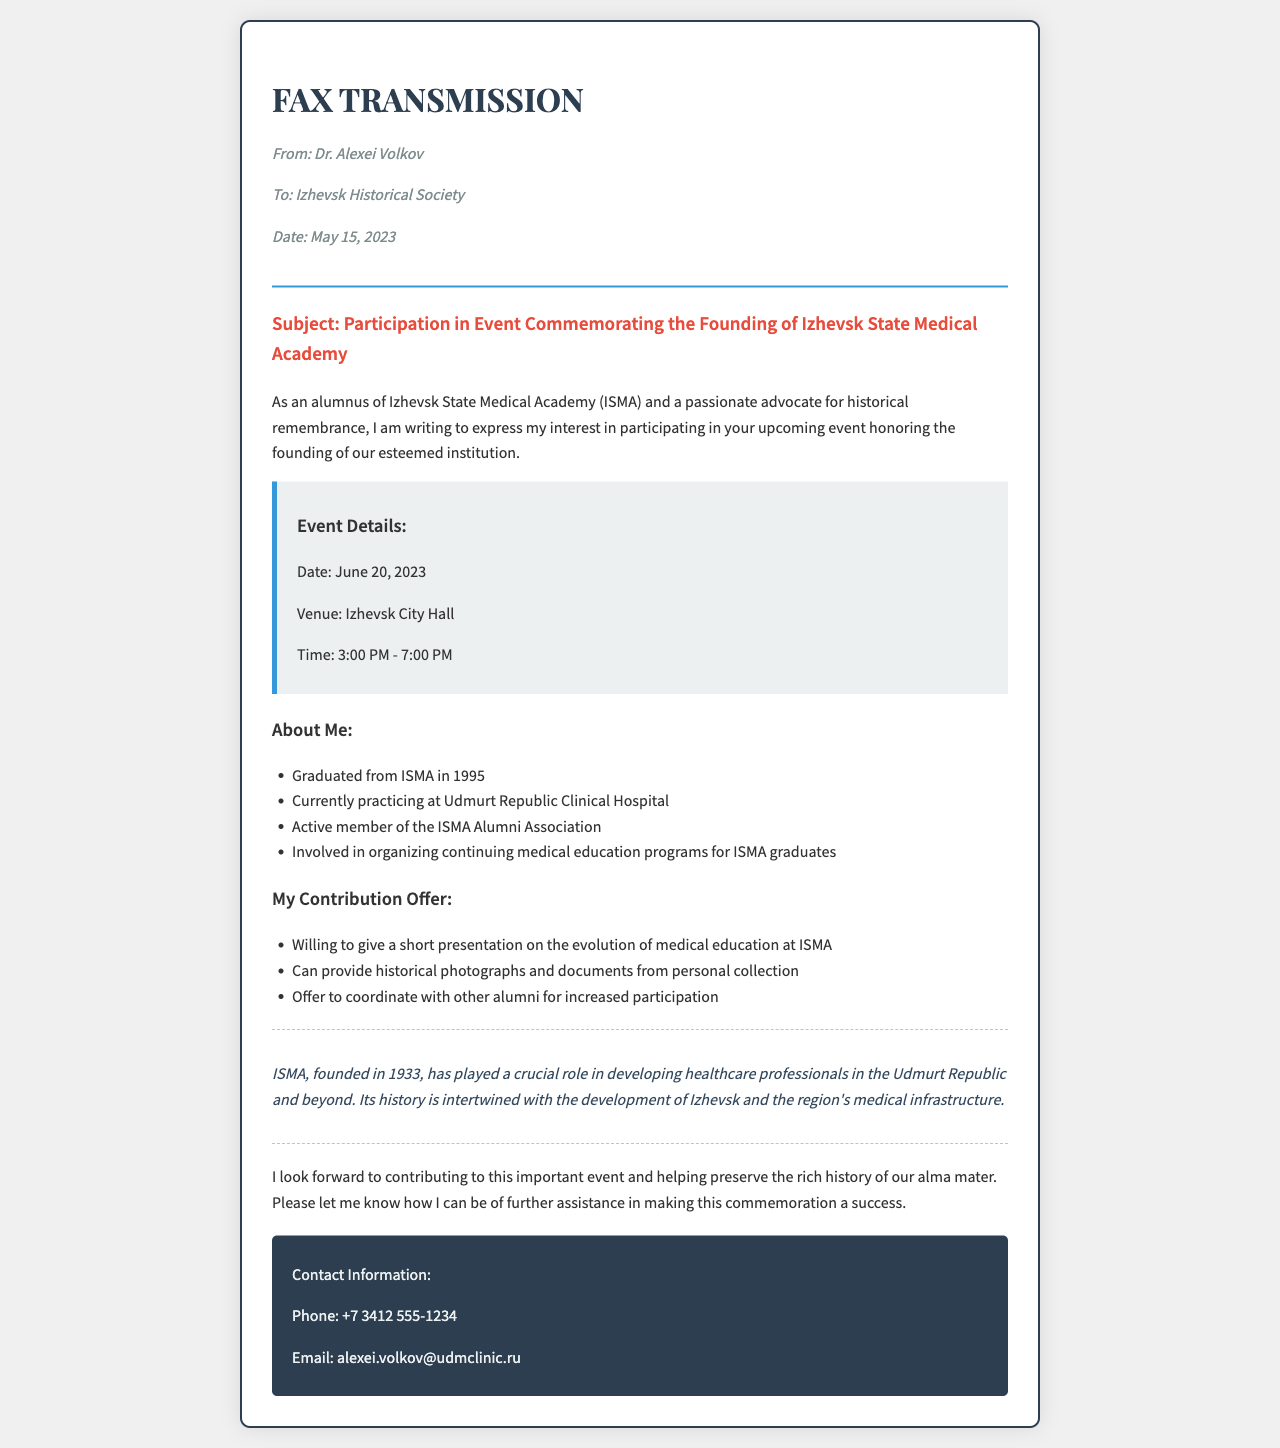What is the date of the event? The date of the event is explicitly mentioned in the event details section of the document.
Answer: June 20, 2023 Who is the sender of the fax? The sender's name is provided in the header section of the document.
Answer: Dr. Alexei Volkov What venue is the event being held at? The venue of the event is stated in the event details section.
Answer: Izhevsk City Hall What is Dr. Volkov's role in the community? Dr. Volkov's involvement in the community is mentioned in his about me section, highlighting his contributions beyond medical practice.
Answer: Active member of the ISMA Alumni Association What presentation will Dr. Volkov give? The specific content of the presentation is outlined in the offering section of the document.
Answer: The evolution of medical education at ISMA How long is the event scheduled to last? The event's start and end times allow for the calculation of its duration.
Answer: 4 hours What is the founding year of ISMA? The founding year of ISMA is explicitly mentioned in the historical significance section.
Answer: 1933 What specific role does Dr. Volkov offer regarding alumni? The document mentions what Dr. Volkov is willing to do in connection with alumni participation.
Answer: Coordinate with other alumni for increased participation What is Dr. Volkov's contact email? The contact email is provided in the contact information section of the document.
Answer: alexei.volkov@udmclinic.ru 